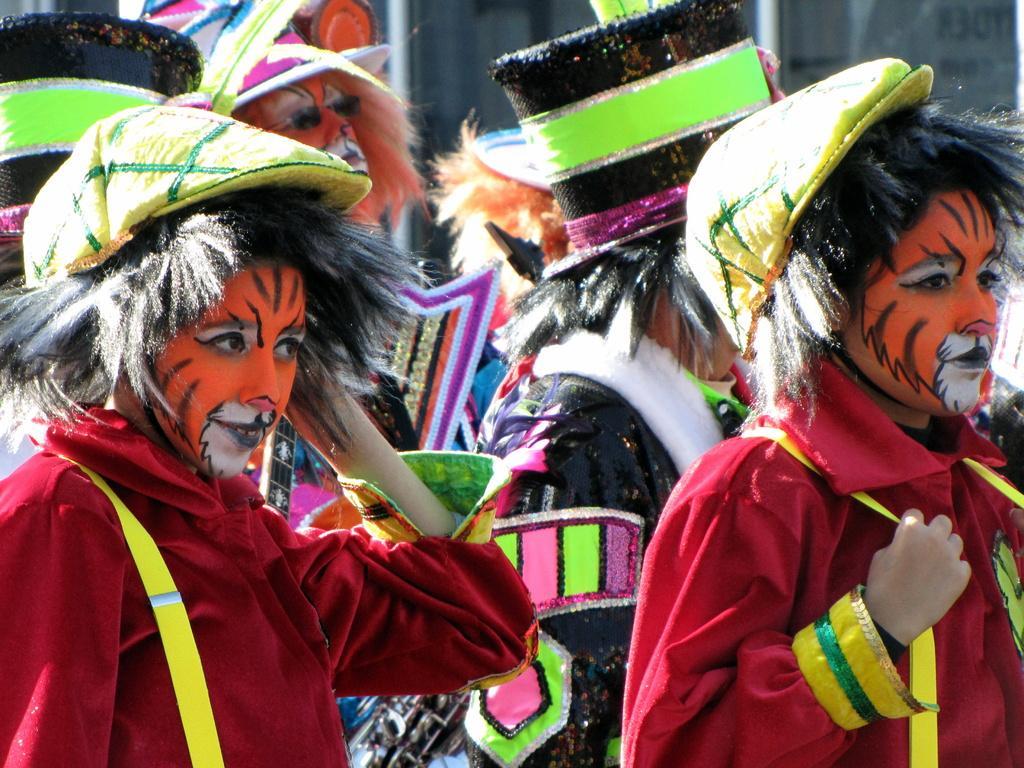How would you summarize this image in a sentence or two? On the left side, there is a person in a red color dress, wearing a cap and smiling. On the right side, there is another person in a red color dress, wearing a cap. In the background, there are other persons. And the background is blurred. 